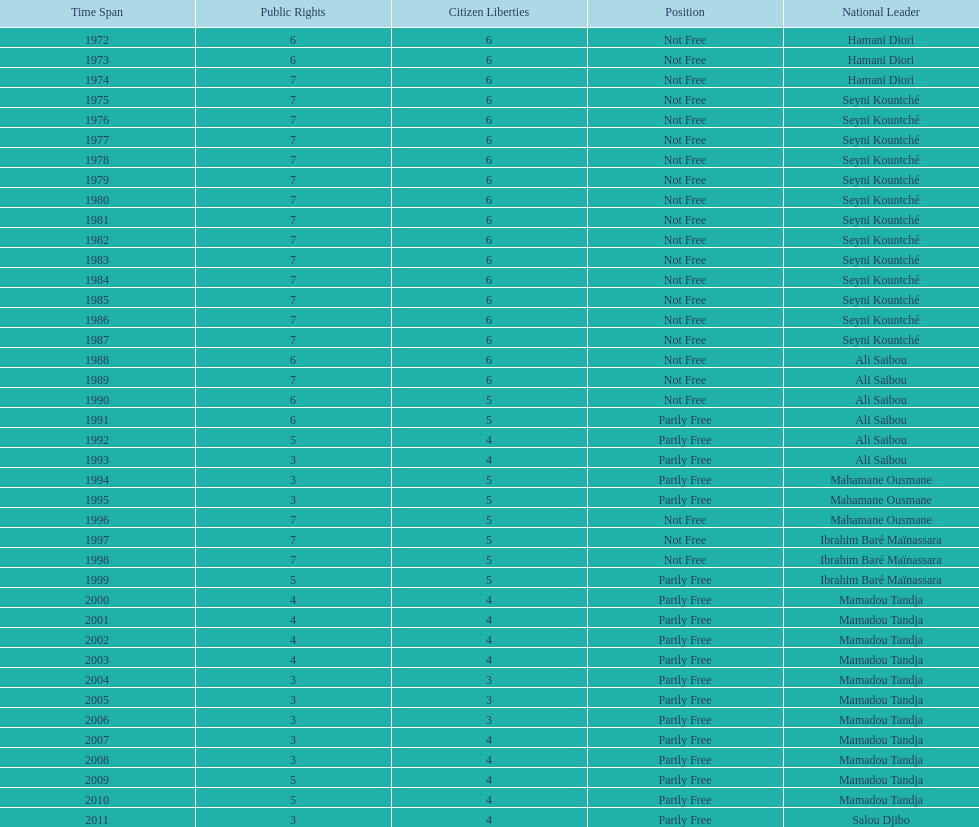Could you parse the entire table as a dict? {'header': ['Time Span', 'Public Rights', 'Citizen Liberties', 'Position', 'National Leader'], 'rows': [['1972', '6', '6', 'Not Free', 'Hamani Diori'], ['1973', '6', '6', 'Not Free', 'Hamani Diori'], ['1974', '7', '6', 'Not Free', 'Hamani Diori'], ['1975', '7', '6', 'Not Free', 'Seyni Kountché'], ['1976', '7', '6', 'Not Free', 'Seyni Kountché'], ['1977', '7', '6', 'Not Free', 'Seyni Kountché'], ['1978', '7', '6', 'Not Free', 'Seyni Kountché'], ['1979', '7', '6', 'Not Free', 'Seyni Kountché'], ['1980', '7', '6', 'Not Free', 'Seyni Kountché'], ['1981', '7', '6', 'Not Free', 'Seyni Kountché'], ['1982', '7', '6', 'Not Free', 'Seyni Kountché'], ['1983', '7', '6', 'Not Free', 'Seyni Kountché'], ['1984', '7', '6', 'Not Free', 'Seyni Kountché'], ['1985', '7', '6', 'Not Free', 'Seyni Kountché'], ['1986', '7', '6', 'Not Free', 'Seyni Kountché'], ['1987', '7', '6', 'Not Free', 'Seyni Kountché'], ['1988', '6', '6', 'Not Free', 'Ali Saibou'], ['1989', '7', '6', 'Not Free', 'Ali Saibou'], ['1990', '6', '5', 'Not Free', 'Ali Saibou'], ['1991', '6', '5', 'Partly Free', 'Ali Saibou'], ['1992', '5', '4', 'Partly Free', 'Ali Saibou'], ['1993', '3', '4', 'Partly Free', 'Ali Saibou'], ['1994', '3', '5', 'Partly Free', 'Mahamane Ousmane'], ['1995', '3', '5', 'Partly Free', 'Mahamane Ousmane'], ['1996', '7', '5', 'Not Free', 'Mahamane Ousmane'], ['1997', '7', '5', 'Not Free', 'Ibrahim Baré Maïnassara'], ['1998', '7', '5', 'Not Free', 'Ibrahim Baré Maïnassara'], ['1999', '5', '5', 'Partly Free', 'Ibrahim Baré Maïnassara'], ['2000', '4', '4', 'Partly Free', 'Mamadou Tandja'], ['2001', '4', '4', 'Partly Free', 'Mamadou Tandja'], ['2002', '4', '4', 'Partly Free', 'Mamadou Tandja'], ['2003', '4', '4', 'Partly Free', 'Mamadou Tandja'], ['2004', '3', '3', 'Partly Free', 'Mamadou Tandja'], ['2005', '3', '3', 'Partly Free', 'Mamadou Tandja'], ['2006', '3', '3', 'Partly Free', 'Mamadou Tandja'], ['2007', '3', '4', 'Partly Free', 'Mamadou Tandja'], ['2008', '3', '4', 'Partly Free', 'Mamadou Tandja'], ['2009', '5', '4', 'Partly Free', 'Mamadou Tandja'], ['2010', '5', '4', 'Partly Free', 'Mamadou Tandja'], ['2011', '3', '4', 'Partly Free', 'Salou Djibo']]} How many years was it before the first partly free status? 18. 